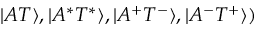Convert formula to latex. <formula><loc_0><loc_0><loc_500><loc_500>| A T \rangle , | A ^ { * } T ^ { * } \rangle , | A ^ { + } T ^ { - } \rangle , | A ^ { - } T ^ { + } \rangle )</formula> 